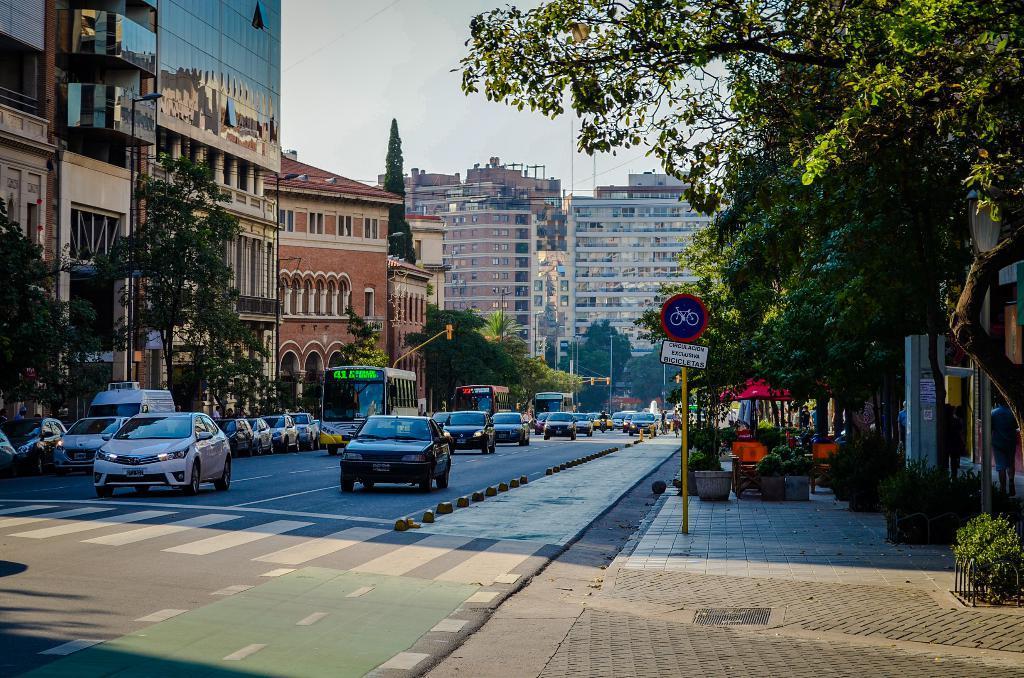Can you describe this image briefly? In the foreground of this image, there are vehicles moving on the road and on the right side of the image, there are trees, plants, sign boards, and building. On the left side of the image, there are trees, buildings, poles, and the sky on the top. 